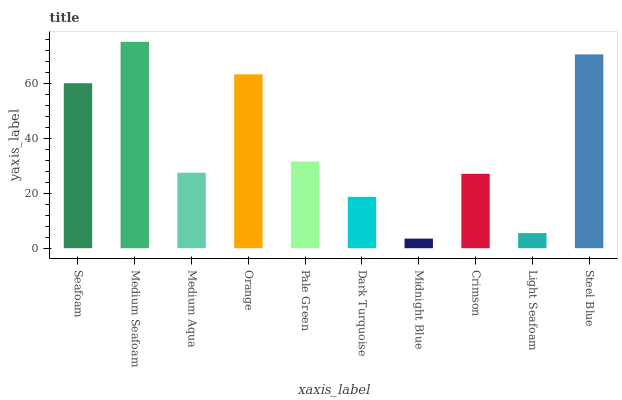Is Medium Aqua the minimum?
Answer yes or no. No. Is Medium Aqua the maximum?
Answer yes or no. No. Is Medium Seafoam greater than Medium Aqua?
Answer yes or no. Yes. Is Medium Aqua less than Medium Seafoam?
Answer yes or no. Yes. Is Medium Aqua greater than Medium Seafoam?
Answer yes or no. No. Is Medium Seafoam less than Medium Aqua?
Answer yes or no. No. Is Pale Green the high median?
Answer yes or no. Yes. Is Medium Aqua the low median?
Answer yes or no. Yes. Is Light Seafoam the high median?
Answer yes or no. No. Is Midnight Blue the low median?
Answer yes or no. No. 